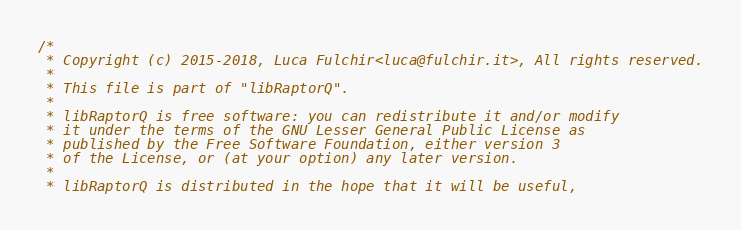Convert code to text. <code><loc_0><loc_0><loc_500><loc_500><_C++_>/*
 * Copyright (c) 2015-2018, Luca Fulchir<luca@fulchir.it>, All rights reserved.
 *
 * This file is part of "libRaptorQ".
 *
 * libRaptorQ is free software: you can redistribute it and/or modify
 * it under the terms of the GNU Lesser General Public License as
 * published by the Free Software Foundation, either version 3
 * of the License, or (at your option) any later version.
 *
 * libRaptorQ is distributed in the hope that it will be useful,</code> 